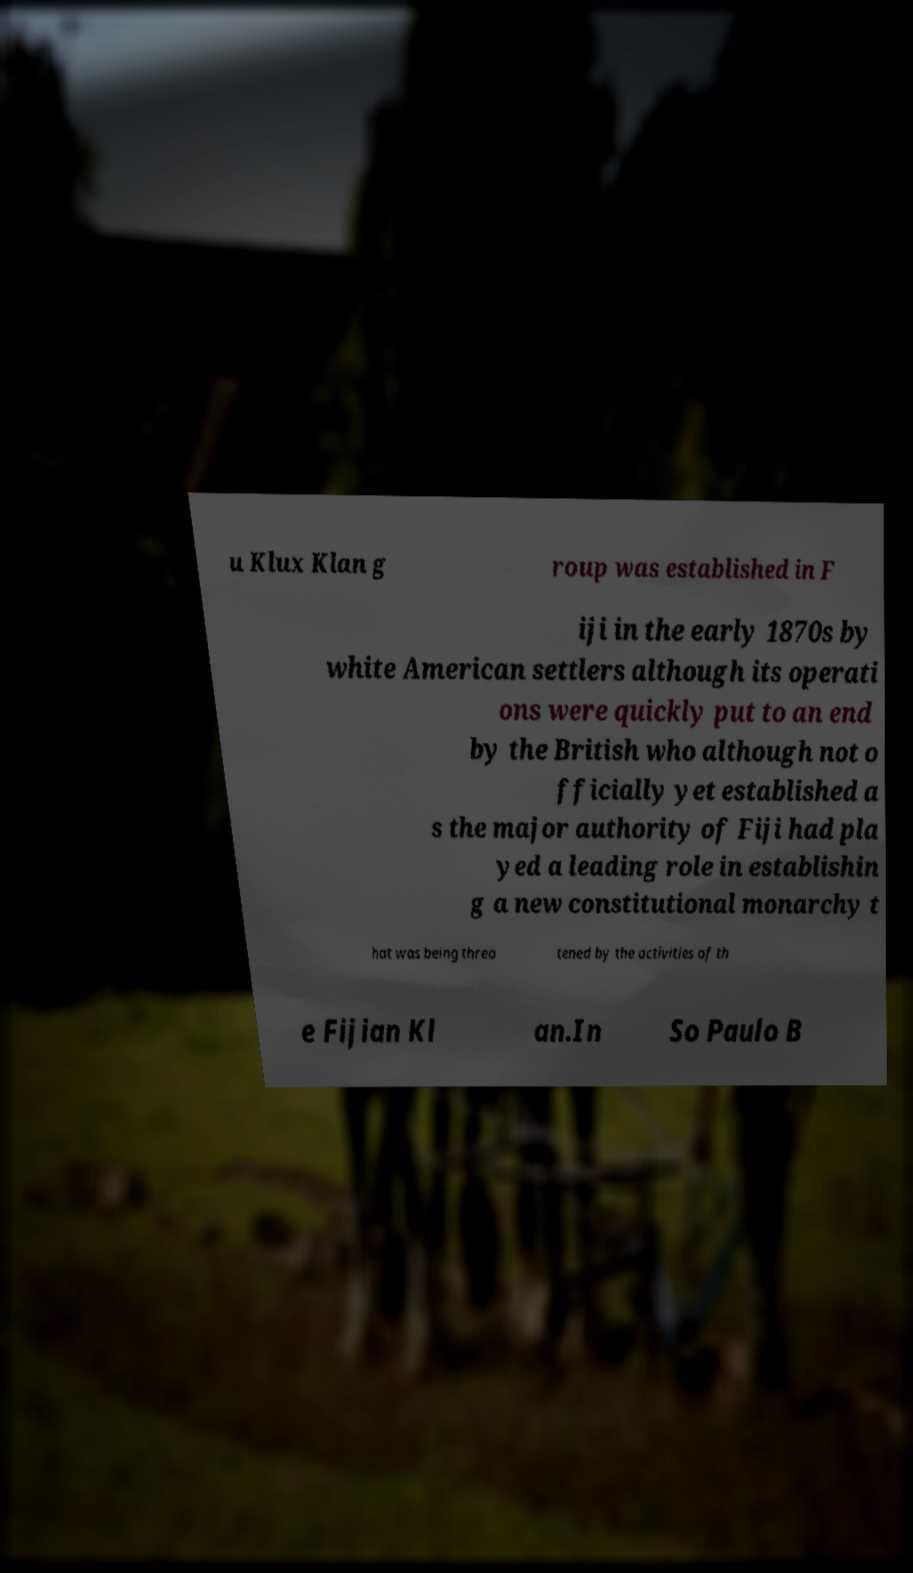There's text embedded in this image that I need extracted. Can you transcribe it verbatim? u Klux Klan g roup was established in F iji in the early 1870s by white American settlers although its operati ons were quickly put to an end by the British who although not o fficially yet established a s the major authority of Fiji had pla yed a leading role in establishin g a new constitutional monarchy t hat was being threa tened by the activities of th e Fijian Kl an.In So Paulo B 